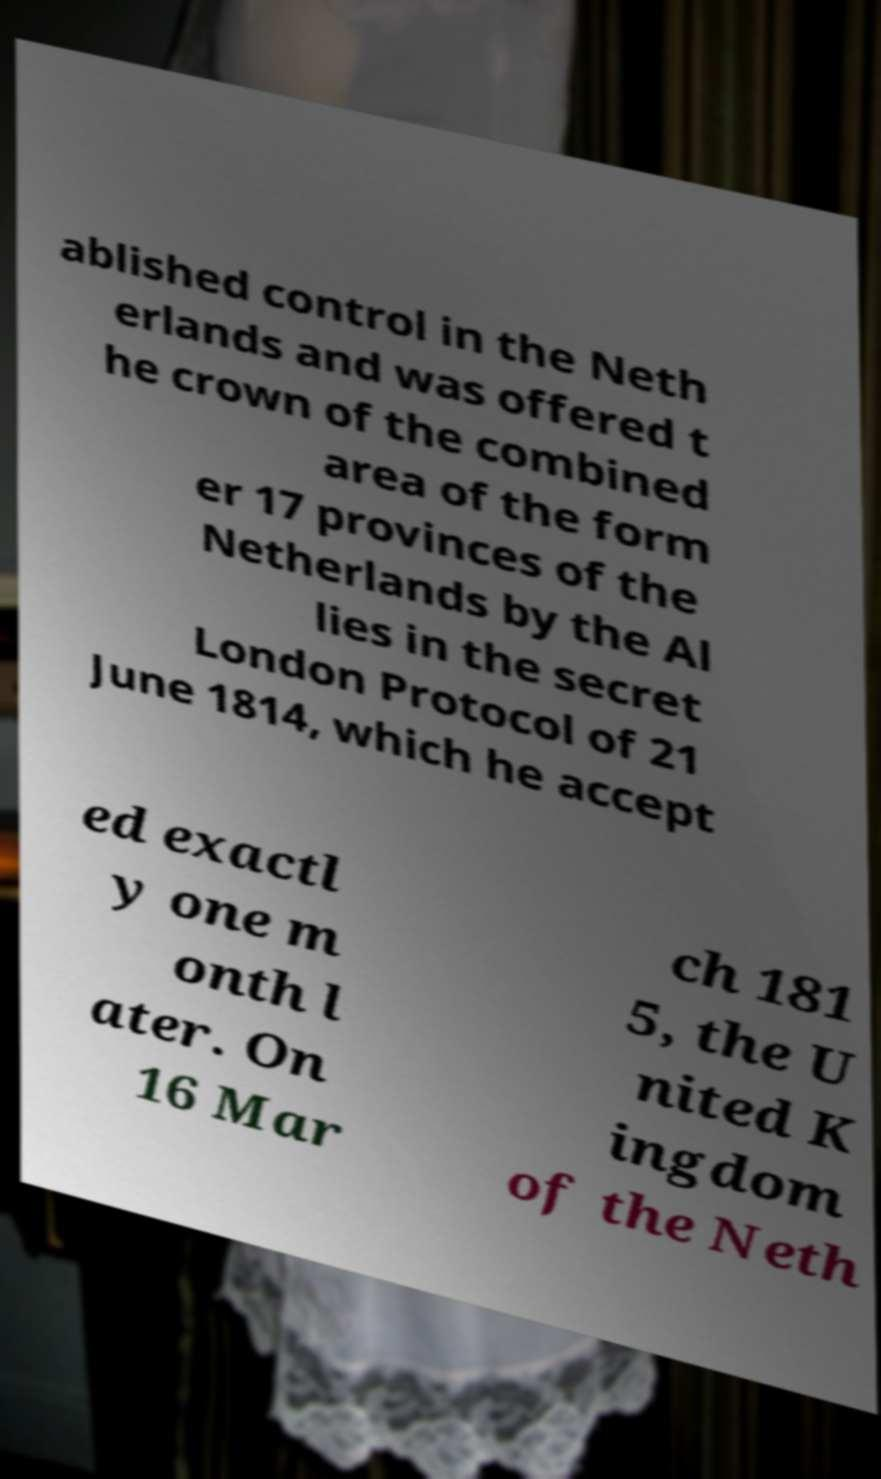Please read and relay the text visible in this image. What does it say? ablished control in the Neth erlands and was offered t he crown of the combined area of the form er 17 provinces of the Netherlands by the Al lies in the secret London Protocol of 21 June 1814, which he accept ed exactl y one m onth l ater. On 16 Mar ch 181 5, the U nited K ingdom of the Neth 